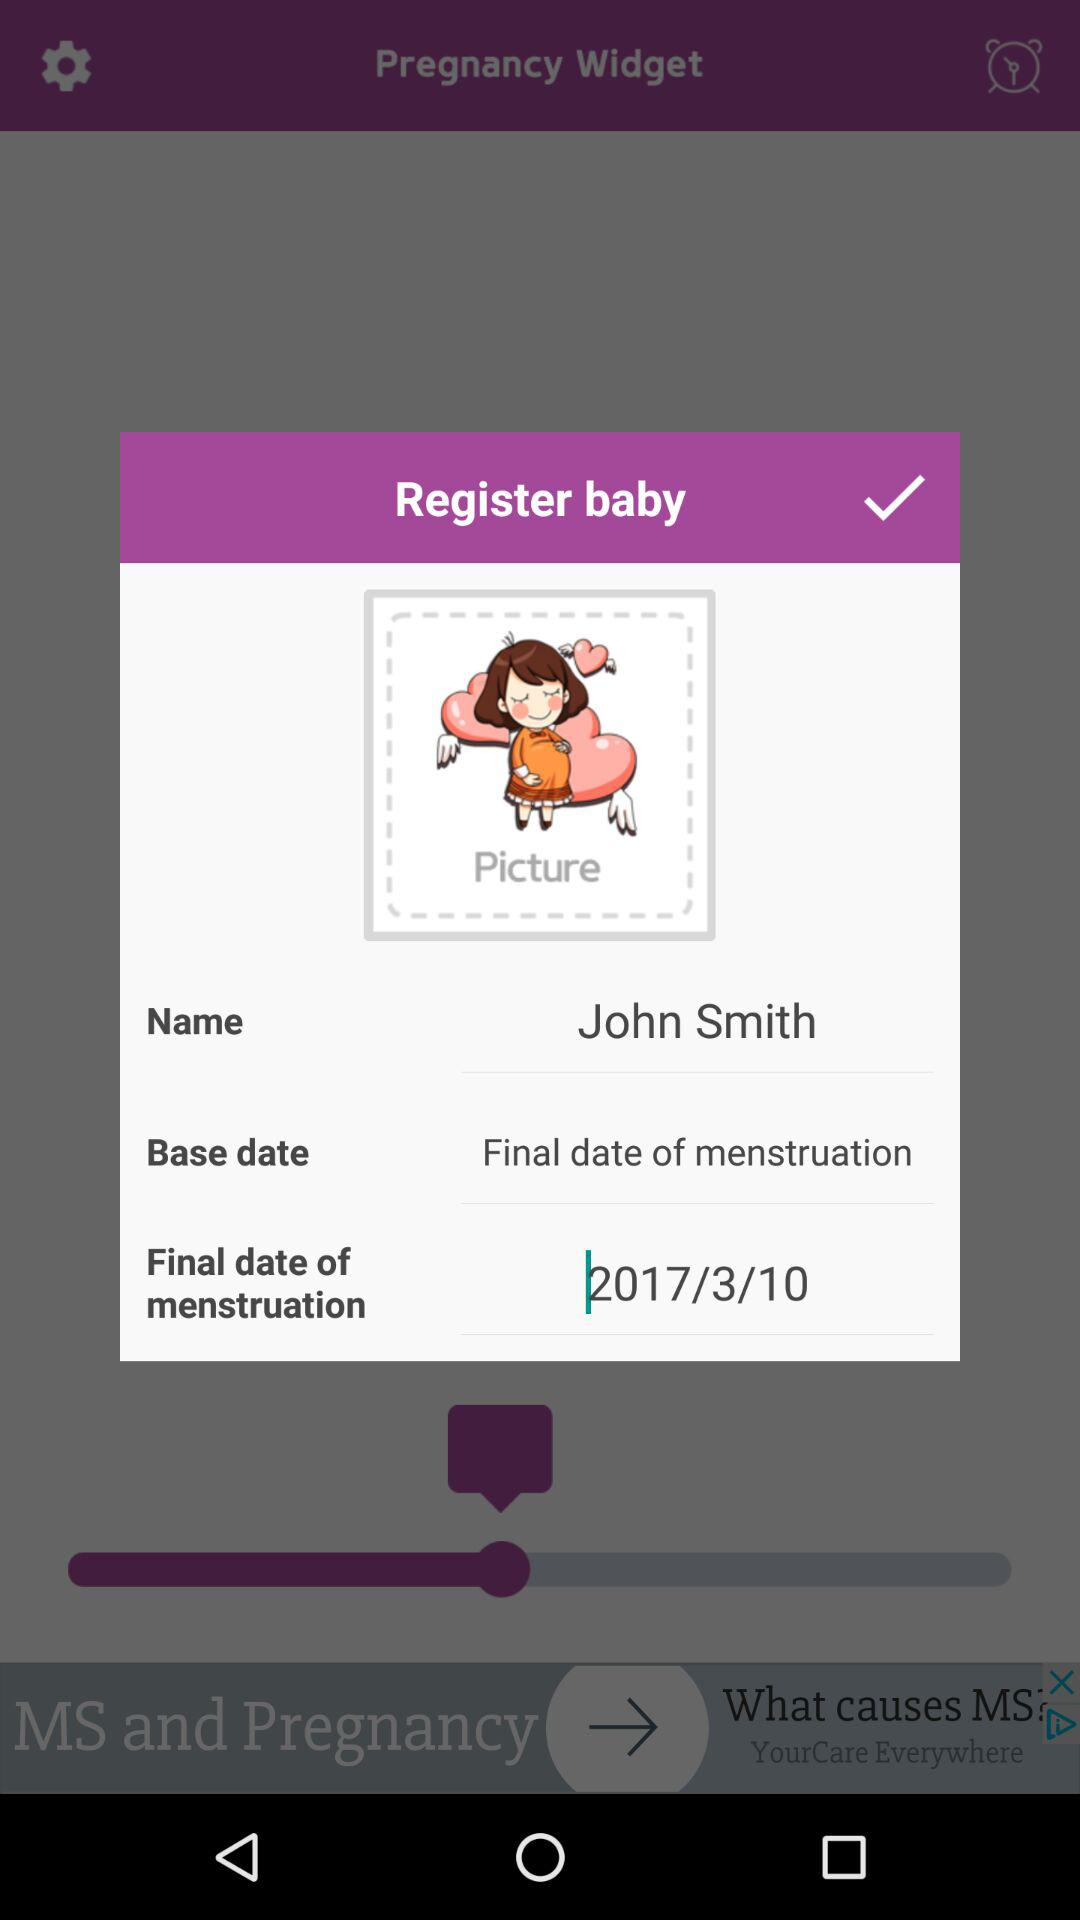What is the final date of menstruation? The final date of menstruation is March 10, 2017. 